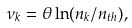<formula> <loc_0><loc_0><loc_500><loc_500>\nu _ { k } = \theta \ln ( n _ { k } / n _ { t h } ) ,</formula> 